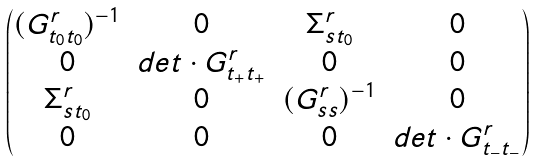Convert formula to latex. <formula><loc_0><loc_0><loc_500><loc_500>\begin{pmatrix} ( G _ { t _ { 0 } t _ { 0 } } ^ { r } ) ^ { - 1 } & 0 & \Sigma _ { s t _ { 0 } } ^ { r } & 0 \\ 0 & d e t \cdot G _ { t _ { + } t _ { + } } ^ { r } & 0 & 0 \\ \Sigma _ { s t _ { 0 } } ^ { r } & 0 & ( G _ { s s } ^ { r } ) ^ { - 1 } & 0 \\ 0 & 0 & 0 & d e t \cdot G _ { t _ { - } t _ { - } } ^ { r } \end{pmatrix}</formula> 